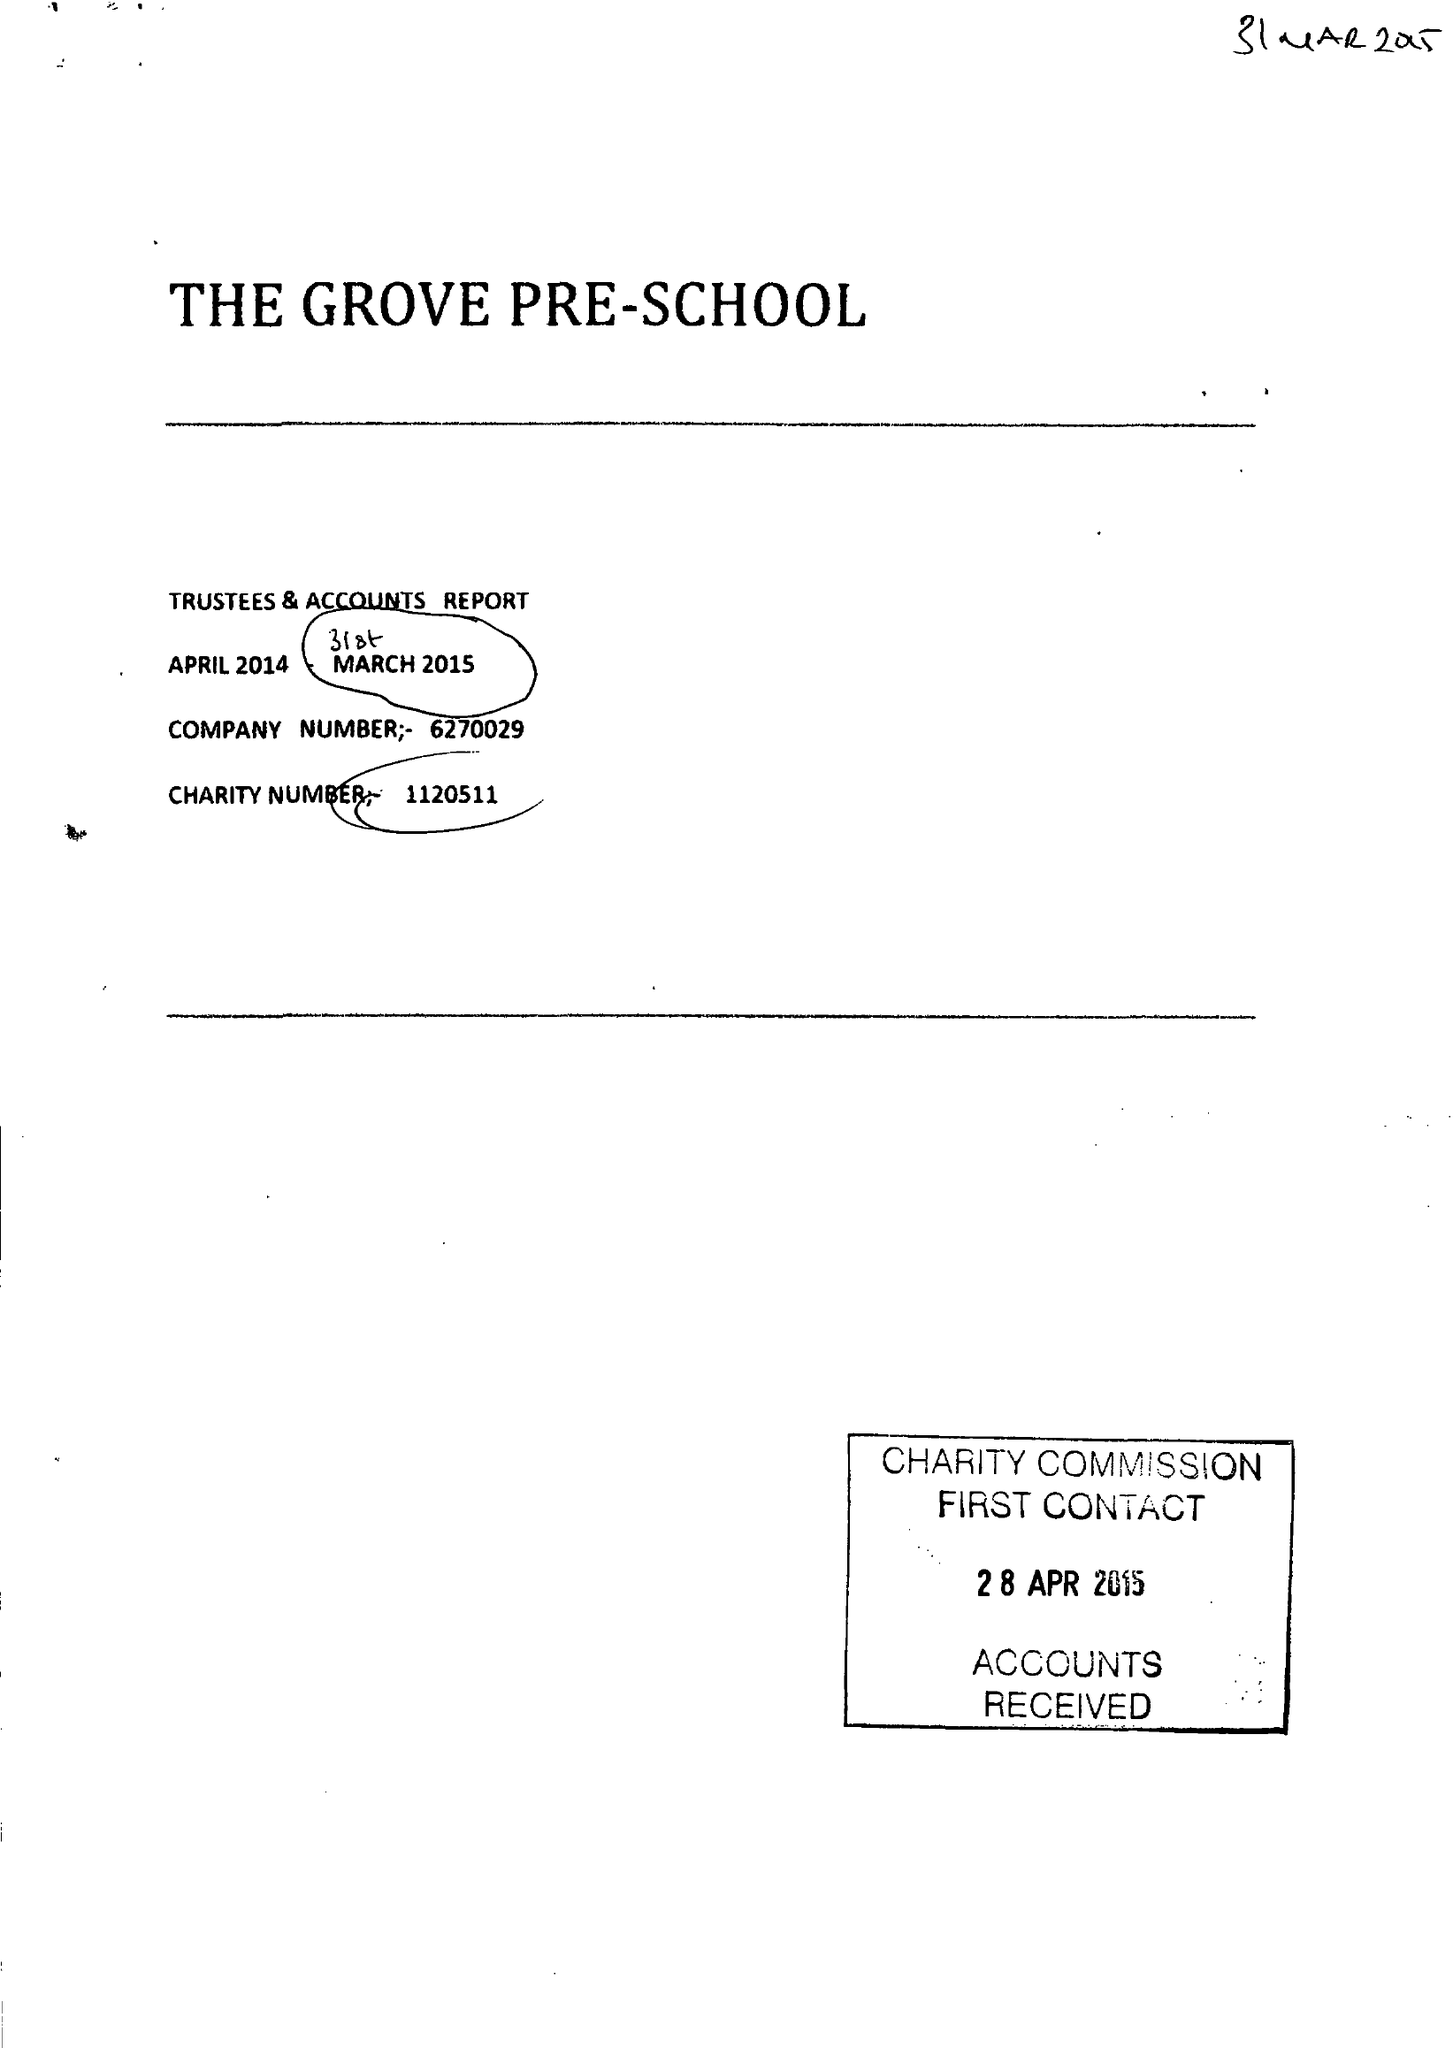What is the value for the charity_number?
Answer the question using a single word or phrase. 1120511 